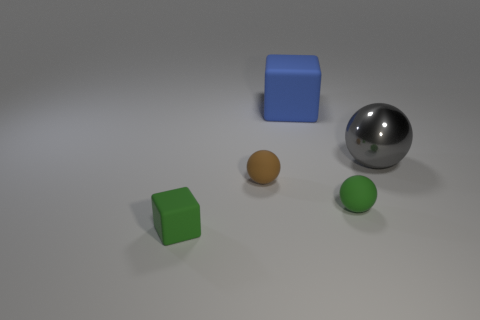Subtract all tiny rubber balls. How many balls are left? 1 Add 3 small cyan metallic cylinders. How many objects exist? 8 Subtract all blue cubes. How many cubes are left? 1 Subtract all balls. How many objects are left? 2 Subtract 1 cubes. How many cubes are left? 1 Subtract 0 purple cylinders. How many objects are left? 5 Subtract all brown blocks. Subtract all yellow balls. How many blocks are left? 2 Subtract all large blocks. Subtract all large cubes. How many objects are left? 3 Add 2 green balls. How many green balls are left? 3 Add 5 small green rubber spheres. How many small green rubber spheres exist? 6 